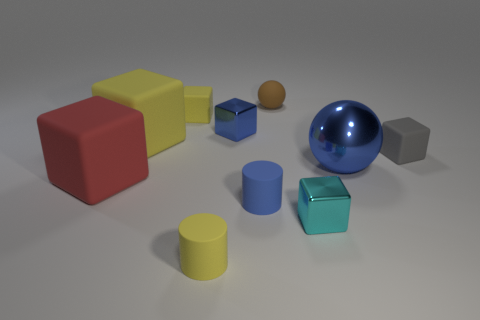Is the shape of the cyan shiny object that is in front of the red block the same as  the brown thing?
Your answer should be compact. No. There is a small object that is the same shape as the big metallic thing; what color is it?
Offer a very short reply. Brown. Is there any other thing that is made of the same material as the small blue block?
Give a very brief answer. Yes. The red object that is the same shape as the gray thing is what size?
Offer a terse response. Large. What is the small thing that is in front of the big red cube and on the right side of the brown ball made of?
Your answer should be very brief. Metal. Is the color of the sphere behind the big blue metal thing the same as the metal sphere?
Your response must be concise. No. There is a large ball; does it have the same color as the small metallic object that is left of the cyan cube?
Ensure brevity in your answer.  Yes. Are there any small yellow rubber cubes in front of the large red block?
Your answer should be very brief. No. Does the cyan thing have the same material as the tiny gray thing?
Provide a succinct answer. No. What material is the brown sphere that is the same size as the cyan block?
Give a very brief answer. Rubber. 